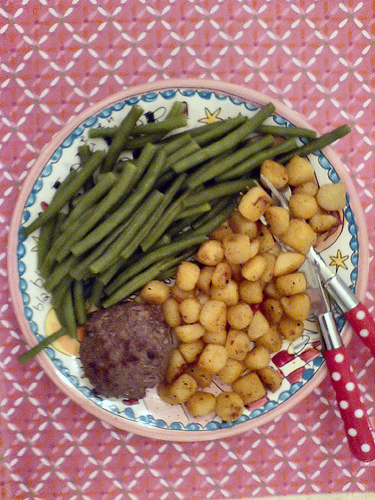<image>
Is the table under the plate? Yes. The table is positioned underneath the plate, with the plate above it in the vertical space. Is there a green beans on the colorful plate? Yes. Looking at the image, I can see the green beans is positioned on top of the colorful plate, with the colorful plate providing support. 